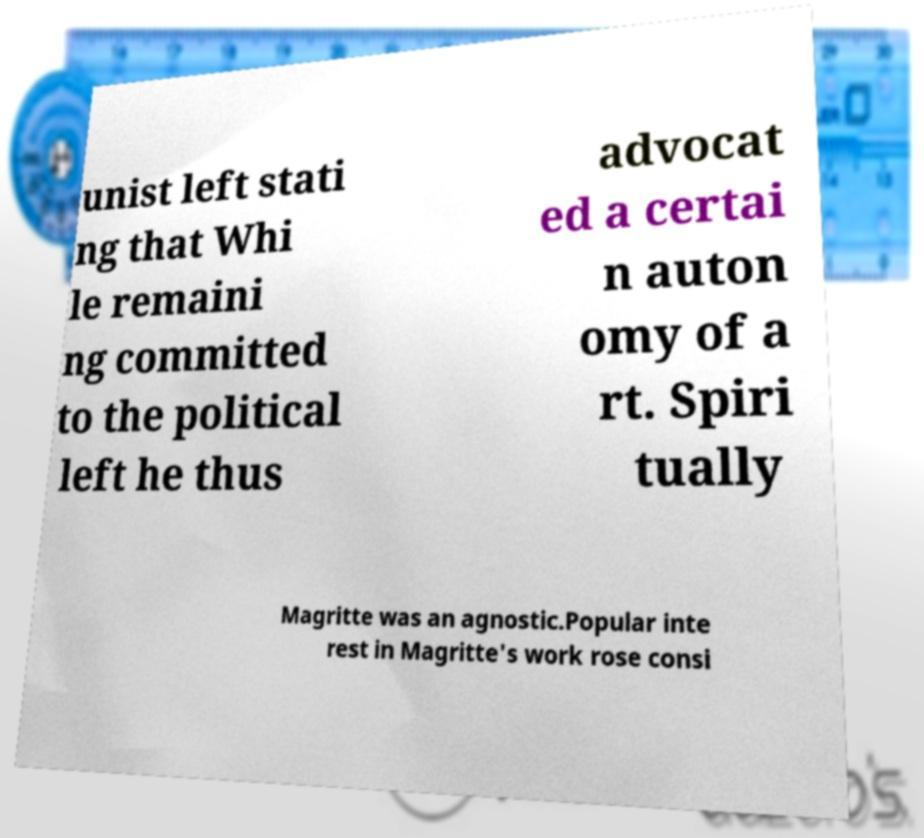Please identify and transcribe the text found in this image. unist left stati ng that Whi le remaini ng committed to the political left he thus advocat ed a certai n auton omy of a rt. Spiri tually Magritte was an agnostic.Popular inte rest in Magritte's work rose consi 